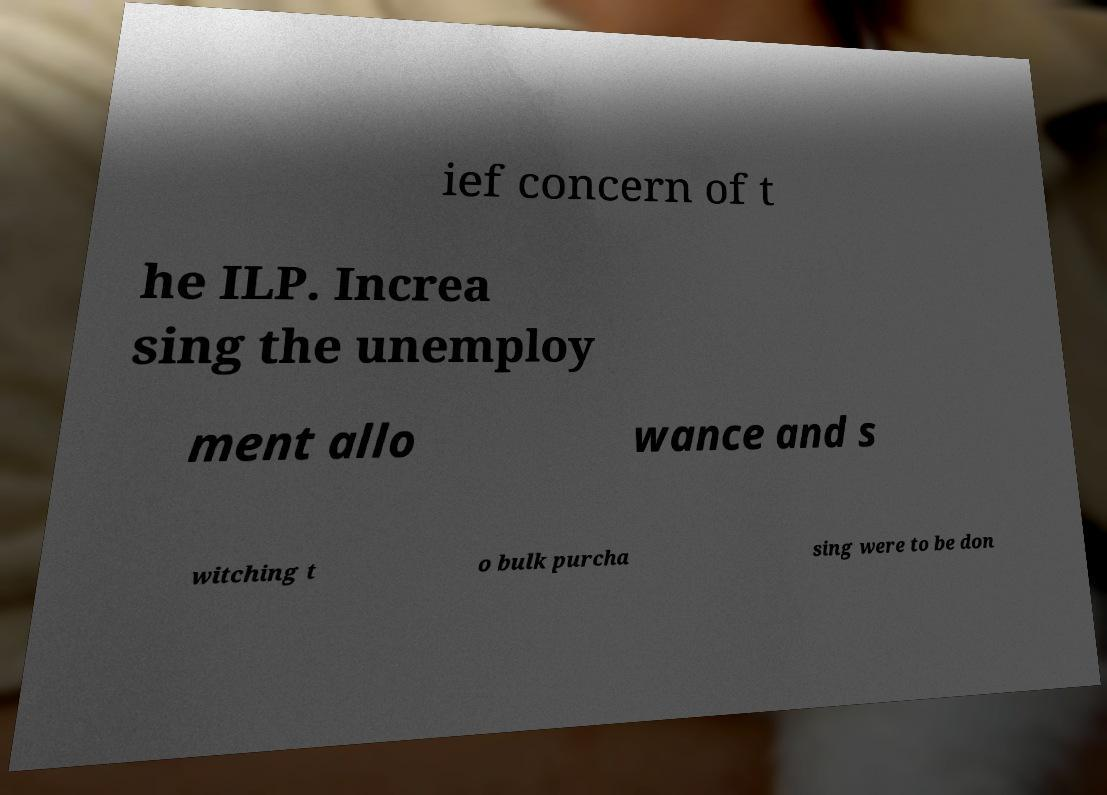What messages or text are displayed in this image? I need them in a readable, typed format. ief concern of t he ILP. Increa sing the unemploy ment allo wance and s witching t o bulk purcha sing were to be don 